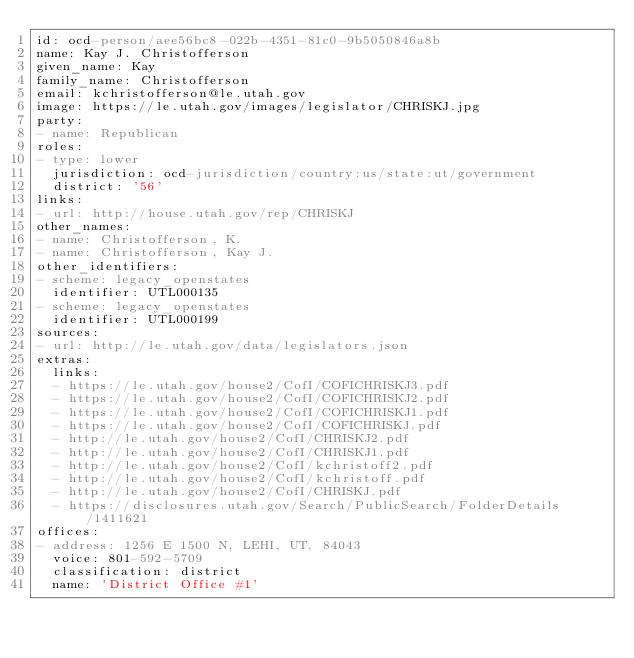Convert code to text. <code><loc_0><loc_0><loc_500><loc_500><_YAML_>id: ocd-person/aee56bc8-022b-4351-81c0-9b5050846a8b
name: Kay J. Christofferson
given_name: Kay
family_name: Christofferson
email: kchristofferson@le.utah.gov
image: https://le.utah.gov/images/legislator/CHRISKJ.jpg
party:
- name: Republican
roles:
- type: lower
  jurisdiction: ocd-jurisdiction/country:us/state:ut/government
  district: '56'
links:
- url: http://house.utah.gov/rep/CHRISKJ
other_names:
- name: Christofferson, K.
- name: Christofferson, Kay J.
other_identifiers:
- scheme: legacy_openstates
  identifier: UTL000135
- scheme: legacy_openstates
  identifier: UTL000199
sources:
- url: http://le.utah.gov/data/legislators.json
extras:
  links:
  - https://le.utah.gov/house2/CofI/COFICHRISKJ3.pdf
  - https://le.utah.gov/house2/CofI/COFICHRISKJ2.pdf
  - https://le.utah.gov/house2/CofI/COFICHRISKJ1.pdf
  - https://le.utah.gov/house2/CofI/COFICHRISKJ.pdf
  - http://le.utah.gov/house2/CofI/CHRISKJ2.pdf
  - http://le.utah.gov/house2/CofI/CHRISKJ1.pdf
  - http://le.utah.gov/house2/CofI/kchristoff2.pdf
  - http://le.utah.gov/house2/CofI/kchristoff.pdf
  - http://le.utah.gov/house2/CofI/CHRISKJ.pdf
  - https://disclosures.utah.gov/Search/PublicSearch/FolderDetails/1411621
offices:
- address: 1256 E 1500 N, LEHI, UT, 84043
  voice: 801-592-5709
  classification: district
  name: 'District Office #1'
</code> 